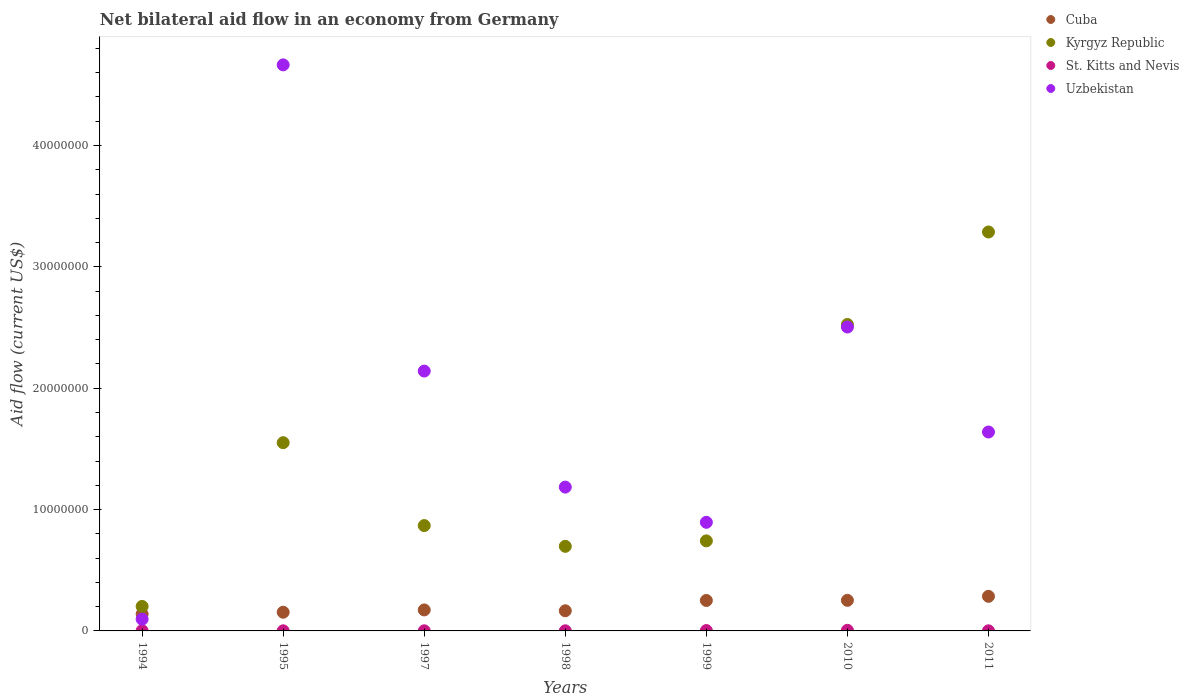What is the net bilateral aid flow in Cuba in 1995?
Provide a short and direct response. 1.54e+06. Across all years, what is the minimum net bilateral aid flow in Cuba?
Your response must be concise. 1.39e+06. What is the total net bilateral aid flow in Kyrgyz Republic in the graph?
Provide a short and direct response. 9.87e+07. What is the difference between the net bilateral aid flow in Uzbekistan in 1995 and that in 2010?
Make the answer very short. 2.16e+07. What is the difference between the net bilateral aid flow in Uzbekistan in 1999 and the net bilateral aid flow in Cuba in 2010?
Give a very brief answer. 6.43e+06. In the year 1997, what is the difference between the net bilateral aid flow in Cuba and net bilateral aid flow in Kyrgyz Republic?
Offer a terse response. -6.95e+06. What is the ratio of the net bilateral aid flow in Kyrgyz Republic in 1997 to that in 2011?
Offer a very short reply. 0.26. Is the net bilateral aid flow in Cuba in 1997 less than that in 1999?
Ensure brevity in your answer.  Yes. Is the difference between the net bilateral aid flow in Cuba in 1995 and 2011 greater than the difference between the net bilateral aid flow in Kyrgyz Republic in 1995 and 2011?
Provide a succinct answer. Yes. What is the difference between the highest and the second highest net bilateral aid flow in Cuba?
Ensure brevity in your answer.  3.30e+05. What is the difference between the highest and the lowest net bilateral aid flow in Uzbekistan?
Your response must be concise. 4.57e+07. In how many years, is the net bilateral aid flow in Uzbekistan greater than the average net bilateral aid flow in Uzbekistan taken over all years?
Your answer should be compact. 3. Is the sum of the net bilateral aid flow in Cuba in 1994 and 1998 greater than the maximum net bilateral aid flow in Uzbekistan across all years?
Offer a terse response. No. Does the net bilateral aid flow in Uzbekistan monotonically increase over the years?
Your answer should be compact. No. How many dotlines are there?
Provide a short and direct response. 4. How many years are there in the graph?
Your answer should be very brief. 7. What is the difference between two consecutive major ticks on the Y-axis?
Give a very brief answer. 1.00e+07. Does the graph contain any zero values?
Your response must be concise. No. Does the graph contain grids?
Offer a terse response. No. Where does the legend appear in the graph?
Your answer should be very brief. Top right. What is the title of the graph?
Provide a succinct answer. Net bilateral aid flow in an economy from Germany. What is the Aid flow (current US$) of Cuba in 1994?
Your answer should be very brief. 1.39e+06. What is the Aid flow (current US$) in Kyrgyz Republic in 1994?
Provide a succinct answer. 2.02e+06. What is the Aid flow (current US$) in Uzbekistan in 1994?
Keep it short and to the point. 9.70e+05. What is the Aid flow (current US$) in Cuba in 1995?
Keep it short and to the point. 1.54e+06. What is the Aid flow (current US$) of Kyrgyz Republic in 1995?
Offer a very short reply. 1.55e+07. What is the Aid flow (current US$) of Uzbekistan in 1995?
Your answer should be very brief. 4.66e+07. What is the Aid flow (current US$) of Cuba in 1997?
Make the answer very short. 1.73e+06. What is the Aid flow (current US$) in Kyrgyz Republic in 1997?
Keep it short and to the point. 8.68e+06. What is the Aid flow (current US$) in St. Kitts and Nevis in 1997?
Offer a terse response. 10000. What is the Aid flow (current US$) in Uzbekistan in 1997?
Ensure brevity in your answer.  2.14e+07. What is the Aid flow (current US$) of Cuba in 1998?
Give a very brief answer. 1.66e+06. What is the Aid flow (current US$) in Kyrgyz Republic in 1998?
Offer a very short reply. 6.97e+06. What is the Aid flow (current US$) in St. Kitts and Nevis in 1998?
Your answer should be very brief. 10000. What is the Aid flow (current US$) in Uzbekistan in 1998?
Provide a short and direct response. 1.18e+07. What is the Aid flow (current US$) in Cuba in 1999?
Offer a terse response. 2.51e+06. What is the Aid flow (current US$) in Kyrgyz Republic in 1999?
Your response must be concise. 7.42e+06. What is the Aid flow (current US$) in St. Kitts and Nevis in 1999?
Give a very brief answer. 3.00e+04. What is the Aid flow (current US$) in Uzbekistan in 1999?
Offer a terse response. 8.95e+06. What is the Aid flow (current US$) in Cuba in 2010?
Provide a succinct answer. 2.52e+06. What is the Aid flow (current US$) of Kyrgyz Republic in 2010?
Give a very brief answer. 2.52e+07. What is the Aid flow (current US$) in Uzbekistan in 2010?
Provide a short and direct response. 2.50e+07. What is the Aid flow (current US$) in Cuba in 2011?
Provide a short and direct response. 2.85e+06. What is the Aid flow (current US$) of Kyrgyz Republic in 2011?
Keep it short and to the point. 3.29e+07. What is the Aid flow (current US$) of Uzbekistan in 2011?
Your response must be concise. 1.64e+07. Across all years, what is the maximum Aid flow (current US$) in Cuba?
Offer a very short reply. 2.85e+06. Across all years, what is the maximum Aid flow (current US$) of Kyrgyz Republic?
Your answer should be compact. 3.29e+07. Across all years, what is the maximum Aid flow (current US$) of St. Kitts and Nevis?
Your response must be concise. 5.00e+04. Across all years, what is the maximum Aid flow (current US$) of Uzbekistan?
Your answer should be very brief. 4.66e+07. Across all years, what is the minimum Aid flow (current US$) in Cuba?
Your answer should be very brief. 1.39e+06. Across all years, what is the minimum Aid flow (current US$) of Kyrgyz Republic?
Offer a terse response. 2.02e+06. Across all years, what is the minimum Aid flow (current US$) of Uzbekistan?
Ensure brevity in your answer.  9.70e+05. What is the total Aid flow (current US$) in Cuba in the graph?
Offer a very short reply. 1.42e+07. What is the total Aid flow (current US$) of Kyrgyz Republic in the graph?
Keep it short and to the point. 9.87e+07. What is the total Aid flow (current US$) of St. Kitts and Nevis in the graph?
Keep it short and to the point. 1.40e+05. What is the total Aid flow (current US$) in Uzbekistan in the graph?
Your answer should be very brief. 1.31e+08. What is the difference between the Aid flow (current US$) in Kyrgyz Republic in 1994 and that in 1995?
Your answer should be very brief. -1.35e+07. What is the difference between the Aid flow (current US$) of Uzbekistan in 1994 and that in 1995?
Your response must be concise. -4.57e+07. What is the difference between the Aid flow (current US$) of Kyrgyz Republic in 1994 and that in 1997?
Offer a terse response. -6.66e+06. What is the difference between the Aid flow (current US$) in St. Kitts and Nevis in 1994 and that in 1997?
Provide a succinct answer. 10000. What is the difference between the Aid flow (current US$) in Uzbekistan in 1994 and that in 1997?
Make the answer very short. -2.04e+07. What is the difference between the Aid flow (current US$) of Kyrgyz Republic in 1994 and that in 1998?
Provide a succinct answer. -4.95e+06. What is the difference between the Aid flow (current US$) in St. Kitts and Nevis in 1994 and that in 1998?
Ensure brevity in your answer.  10000. What is the difference between the Aid flow (current US$) in Uzbekistan in 1994 and that in 1998?
Give a very brief answer. -1.09e+07. What is the difference between the Aid flow (current US$) in Cuba in 1994 and that in 1999?
Your response must be concise. -1.12e+06. What is the difference between the Aid flow (current US$) of Kyrgyz Republic in 1994 and that in 1999?
Offer a very short reply. -5.40e+06. What is the difference between the Aid flow (current US$) of Uzbekistan in 1994 and that in 1999?
Keep it short and to the point. -7.98e+06. What is the difference between the Aid flow (current US$) of Cuba in 1994 and that in 2010?
Keep it short and to the point. -1.13e+06. What is the difference between the Aid flow (current US$) of Kyrgyz Republic in 1994 and that in 2010?
Your answer should be compact. -2.32e+07. What is the difference between the Aid flow (current US$) of St. Kitts and Nevis in 1994 and that in 2010?
Give a very brief answer. -3.00e+04. What is the difference between the Aid flow (current US$) in Uzbekistan in 1994 and that in 2010?
Keep it short and to the point. -2.41e+07. What is the difference between the Aid flow (current US$) in Cuba in 1994 and that in 2011?
Offer a terse response. -1.46e+06. What is the difference between the Aid flow (current US$) of Kyrgyz Republic in 1994 and that in 2011?
Keep it short and to the point. -3.08e+07. What is the difference between the Aid flow (current US$) in Uzbekistan in 1994 and that in 2011?
Make the answer very short. -1.54e+07. What is the difference between the Aid flow (current US$) in Kyrgyz Republic in 1995 and that in 1997?
Provide a succinct answer. 6.83e+06. What is the difference between the Aid flow (current US$) of St. Kitts and Nevis in 1995 and that in 1997?
Provide a short and direct response. 0. What is the difference between the Aid flow (current US$) of Uzbekistan in 1995 and that in 1997?
Offer a very short reply. 2.52e+07. What is the difference between the Aid flow (current US$) in Kyrgyz Republic in 1995 and that in 1998?
Your answer should be very brief. 8.54e+06. What is the difference between the Aid flow (current US$) in St. Kitts and Nevis in 1995 and that in 1998?
Provide a short and direct response. 0. What is the difference between the Aid flow (current US$) in Uzbekistan in 1995 and that in 1998?
Your response must be concise. 3.48e+07. What is the difference between the Aid flow (current US$) in Cuba in 1995 and that in 1999?
Your answer should be very brief. -9.70e+05. What is the difference between the Aid flow (current US$) in Kyrgyz Republic in 1995 and that in 1999?
Give a very brief answer. 8.09e+06. What is the difference between the Aid flow (current US$) in Uzbekistan in 1995 and that in 1999?
Your answer should be very brief. 3.77e+07. What is the difference between the Aid flow (current US$) of Cuba in 1995 and that in 2010?
Provide a succinct answer. -9.80e+05. What is the difference between the Aid flow (current US$) of Kyrgyz Republic in 1995 and that in 2010?
Give a very brief answer. -9.74e+06. What is the difference between the Aid flow (current US$) of St. Kitts and Nevis in 1995 and that in 2010?
Give a very brief answer. -4.00e+04. What is the difference between the Aid flow (current US$) in Uzbekistan in 1995 and that in 2010?
Your answer should be compact. 2.16e+07. What is the difference between the Aid flow (current US$) of Cuba in 1995 and that in 2011?
Give a very brief answer. -1.31e+06. What is the difference between the Aid flow (current US$) in Kyrgyz Republic in 1995 and that in 2011?
Provide a short and direct response. -1.74e+07. What is the difference between the Aid flow (current US$) of Uzbekistan in 1995 and that in 2011?
Offer a terse response. 3.02e+07. What is the difference between the Aid flow (current US$) of Cuba in 1997 and that in 1998?
Offer a terse response. 7.00e+04. What is the difference between the Aid flow (current US$) of Kyrgyz Republic in 1997 and that in 1998?
Keep it short and to the point. 1.71e+06. What is the difference between the Aid flow (current US$) of St. Kitts and Nevis in 1997 and that in 1998?
Your answer should be very brief. 0. What is the difference between the Aid flow (current US$) in Uzbekistan in 1997 and that in 1998?
Keep it short and to the point. 9.56e+06. What is the difference between the Aid flow (current US$) in Cuba in 1997 and that in 1999?
Provide a succinct answer. -7.80e+05. What is the difference between the Aid flow (current US$) of Kyrgyz Republic in 1997 and that in 1999?
Offer a terse response. 1.26e+06. What is the difference between the Aid flow (current US$) in St. Kitts and Nevis in 1997 and that in 1999?
Your response must be concise. -2.00e+04. What is the difference between the Aid flow (current US$) of Uzbekistan in 1997 and that in 1999?
Your answer should be compact. 1.25e+07. What is the difference between the Aid flow (current US$) in Cuba in 1997 and that in 2010?
Offer a very short reply. -7.90e+05. What is the difference between the Aid flow (current US$) of Kyrgyz Republic in 1997 and that in 2010?
Provide a succinct answer. -1.66e+07. What is the difference between the Aid flow (current US$) in St. Kitts and Nevis in 1997 and that in 2010?
Offer a terse response. -4.00e+04. What is the difference between the Aid flow (current US$) in Uzbekistan in 1997 and that in 2010?
Your response must be concise. -3.63e+06. What is the difference between the Aid flow (current US$) of Cuba in 1997 and that in 2011?
Provide a short and direct response. -1.12e+06. What is the difference between the Aid flow (current US$) in Kyrgyz Republic in 1997 and that in 2011?
Ensure brevity in your answer.  -2.42e+07. What is the difference between the Aid flow (current US$) of St. Kitts and Nevis in 1997 and that in 2011?
Give a very brief answer. 0. What is the difference between the Aid flow (current US$) in Uzbekistan in 1997 and that in 2011?
Ensure brevity in your answer.  5.02e+06. What is the difference between the Aid flow (current US$) in Cuba in 1998 and that in 1999?
Ensure brevity in your answer.  -8.50e+05. What is the difference between the Aid flow (current US$) of Kyrgyz Republic in 1998 and that in 1999?
Keep it short and to the point. -4.50e+05. What is the difference between the Aid flow (current US$) of St. Kitts and Nevis in 1998 and that in 1999?
Your response must be concise. -2.00e+04. What is the difference between the Aid flow (current US$) in Uzbekistan in 1998 and that in 1999?
Your response must be concise. 2.90e+06. What is the difference between the Aid flow (current US$) of Cuba in 1998 and that in 2010?
Offer a very short reply. -8.60e+05. What is the difference between the Aid flow (current US$) of Kyrgyz Republic in 1998 and that in 2010?
Offer a terse response. -1.83e+07. What is the difference between the Aid flow (current US$) in St. Kitts and Nevis in 1998 and that in 2010?
Make the answer very short. -4.00e+04. What is the difference between the Aid flow (current US$) of Uzbekistan in 1998 and that in 2010?
Your answer should be compact. -1.32e+07. What is the difference between the Aid flow (current US$) of Cuba in 1998 and that in 2011?
Provide a short and direct response. -1.19e+06. What is the difference between the Aid flow (current US$) of Kyrgyz Republic in 1998 and that in 2011?
Offer a very short reply. -2.59e+07. What is the difference between the Aid flow (current US$) in Uzbekistan in 1998 and that in 2011?
Your answer should be compact. -4.54e+06. What is the difference between the Aid flow (current US$) of Kyrgyz Republic in 1999 and that in 2010?
Ensure brevity in your answer.  -1.78e+07. What is the difference between the Aid flow (current US$) of St. Kitts and Nevis in 1999 and that in 2010?
Give a very brief answer. -2.00e+04. What is the difference between the Aid flow (current US$) in Uzbekistan in 1999 and that in 2010?
Offer a very short reply. -1.61e+07. What is the difference between the Aid flow (current US$) in Kyrgyz Republic in 1999 and that in 2011?
Ensure brevity in your answer.  -2.54e+07. What is the difference between the Aid flow (current US$) of St. Kitts and Nevis in 1999 and that in 2011?
Make the answer very short. 2.00e+04. What is the difference between the Aid flow (current US$) of Uzbekistan in 1999 and that in 2011?
Your response must be concise. -7.44e+06. What is the difference between the Aid flow (current US$) in Cuba in 2010 and that in 2011?
Your answer should be very brief. -3.30e+05. What is the difference between the Aid flow (current US$) in Kyrgyz Republic in 2010 and that in 2011?
Offer a terse response. -7.62e+06. What is the difference between the Aid flow (current US$) of St. Kitts and Nevis in 2010 and that in 2011?
Give a very brief answer. 4.00e+04. What is the difference between the Aid flow (current US$) in Uzbekistan in 2010 and that in 2011?
Your answer should be compact. 8.65e+06. What is the difference between the Aid flow (current US$) in Cuba in 1994 and the Aid flow (current US$) in Kyrgyz Republic in 1995?
Your response must be concise. -1.41e+07. What is the difference between the Aid flow (current US$) in Cuba in 1994 and the Aid flow (current US$) in St. Kitts and Nevis in 1995?
Your response must be concise. 1.38e+06. What is the difference between the Aid flow (current US$) of Cuba in 1994 and the Aid flow (current US$) of Uzbekistan in 1995?
Provide a short and direct response. -4.52e+07. What is the difference between the Aid flow (current US$) in Kyrgyz Republic in 1994 and the Aid flow (current US$) in St. Kitts and Nevis in 1995?
Your answer should be compact. 2.01e+06. What is the difference between the Aid flow (current US$) of Kyrgyz Republic in 1994 and the Aid flow (current US$) of Uzbekistan in 1995?
Your response must be concise. -4.46e+07. What is the difference between the Aid flow (current US$) in St. Kitts and Nevis in 1994 and the Aid flow (current US$) in Uzbekistan in 1995?
Provide a short and direct response. -4.66e+07. What is the difference between the Aid flow (current US$) of Cuba in 1994 and the Aid flow (current US$) of Kyrgyz Republic in 1997?
Provide a succinct answer. -7.29e+06. What is the difference between the Aid flow (current US$) in Cuba in 1994 and the Aid flow (current US$) in St. Kitts and Nevis in 1997?
Your answer should be very brief. 1.38e+06. What is the difference between the Aid flow (current US$) of Cuba in 1994 and the Aid flow (current US$) of Uzbekistan in 1997?
Your response must be concise. -2.00e+07. What is the difference between the Aid flow (current US$) of Kyrgyz Republic in 1994 and the Aid flow (current US$) of St. Kitts and Nevis in 1997?
Keep it short and to the point. 2.01e+06. What is the difference between the Aid flow (current US$) of Kyrgyz Republic in 1994 and the Aid flow (current US$) of Uzbekistan in 1997?
Offer a terse response. -1.94e+07. What is the difference between the Aid flow (current US$) in St. Kitts and Nevis in 1994 and the Aid flow (current US$) in Uzbekistan in 1997?
Offer a very short reply. -2.14e+07. What is the difference between the Aid flow (current US$) of Cuba in 1994 and the Aid flow (current US$) of Kyrgyz Republic in 1998?
Your answer should be very brief. -5.58e+06. What is the difference between the Aid flow (current US$) in Cuba in 1994 and the Aid flow (current US$) in St. Kitts and Nevis in 1998?
Provide a short and direct response. 1.38e+06. What is the difference between the Aid flow (current US$) of Cuba in 1994 and the Aid flow (current US$) of Uzbekistan in 1998?
Provide a short and direct response. -1.05e+07. What is the difference between the Aid flow (current US$) in Kyrgyz Republic in 1994 and the Aid flow (current US$) in St. Kitts and Nevis in 1998?
Your answer should be compact. 2.01e+06. What is the difference between the Aid flow (current US$) of Kyrgyz Republic in 1994 and the Aid flow (current US$) of Uzbekistan in 1998?
Ensure brevity in your answer.  -9.83e+06. What is the difference between the Aid flow (current US$) of St. Kitts and Nevis in 1994 and the Aid flow (current US$) of Uzbekistan in 1998?
Offer a very short reply. -1.18e+07. What is the difference between the Aid flow (current US$) in Cuba in 1994 and the Aid flow (current US$) in Kyrgyz Republic in 1999?
Keep it short and to the point. -6.03e+06. What is the difference between the Aid flow (current US$) in Cuba in 1994 and the Aid flow (current US$) in St. Kitts and Nevis in 1999?
Keep it short and to the point. 1.36e+06. What is the difference between the Aid flow (current US$) of Cuba in 1994 and the Aid flow (current US$) of Uzbekistan in 1999?
Make the answer very short. -7.56e+06. What is the difference between the Aid flow (current US$) in Kyrgyz Republic in 1994 and the Aid flow (current US$) in St. Kitts and Nevis in 1999?
Your answer should be very brief. 1.99e+06. What is the difference between the Aid flow (current US$) of Kyrgyz Republic in 1994 and the Aid flow (current US$) of Uzbekistan in 1999?
Ensure brevity in your answer.  -6.93e+06. What is the difference between the Aid flow (current US$) in St. Kitts and Nevis in 1994 and the Aid flow (current US$) in Uzbekistan in 1999?
Your answer should be very brief. -8.93e+06. What is the difference between the Aid flow (current US$) in Cuba in 1994 and the Aid flow (current US$) in Kyrgyz Republic in 2010?
Provide a short and direct response. -2.39e+07. What is the difference between the Aid flow (current US$) in Cuba in 1994 and the Aid flow (current US$) in St. Kitts and Nevis in 2010?
Ensure brevity in your answer.  1.34e+06. What is the difference between the Aid flow (current US$) of Cuba in 1994 and the Aid flow (current US$) of Uzbekistan in 2010?
Provide a succinct answer. -2.36e+07. What is the difference between the Aid flow (current US$) of Kyrgyz Republic in 1994 and the Aid flow (current US$) of St. Kitts and Nevis in 2010?
Your answer should be compact. 1.97e+06. What is the difference between the Aid flow (current US$) of Kyrgyz Republic in 1994 and the Aid flow (current US$) of Uzbekistan in 2010?
Your response must be concise. -2.30e+07. What is the difference between the Aid flow (current US$) in St. Kitts and Nevis in 1994 and the Aid flow (current US$) in Uzbekistan in 2010?
Your answer should be compact. -2.50e+07. What is the difference between the Aid flow (current US$) of Cuba in 1994 and the Aid flow (current US$) of Kyrgyz Republic in 2011?
Make the answer very short. -3.15e+07. What is the difference between the Aid flow (current US$) of Cuba in 1994 and the Aid flow (current US$) of St. Kitts and Nevis in 2011?
Your answer should be compact. 1.38e+06. What is the difference between the Aid flow (current US$) of Cuba in 1994 and the Aid flow (current US$) of Uzbekistan in 2011?
Ensure brevity in your answer.  -1.50e+07. What is the difference between the Aid flow (current US$) in Kyrgyz Republic in 1994 and the Aid flow (current US$) in St. Kitts and Nevis in 2011?
Make the answer very short. 2.01e+06. What is the difference between the Aid flow (current US$) in Kyrgyz Republic in 1994 and the Aid flow (current US$) in Uzbekistan in 2011?
Ensure brevity in your answer.  -1.44e+07. What is the difference between the Aid flow (current US$) of St. Kitts and Nevis in 1994 and the Aid flow (current US$) of Uzbekistan in 2011?
Make the answer very short. -1.64e+07. What is the difference between the Aid flow (current US$) in Cuba in 1995 and the Aid flow (current US$) in Kyrgyz Republic in 1997?
Your answer should be compact. -7.14e+06. What is the difference between the Aid flow (current US$) in Cuba in 1995 and the Aid flow (current US$) in St. Kitts and Nevis in 1997?
Your response must be concise. 1.53e+06. What is the difference between the Aid flow (current US$) of Cuba in 1995 and the Aid flow (current US$) of Uzbekistan in 1997?
Keep it short and to the point. -1.99e+07. What is the difference between the Aid flow (current US$) of Kyrgyz Republic in 1995 and the Aid flow (current US$) of St. Kitts and Nevis in 1997?
Offer a very short reply. 1.55e+07. What is the difference between the Aid flow (current US$) in Kyrgyz Republic in 1995 and the Aid flow (current US$) in Uzbekistan in 1997?
Provide a succinct answer. -5.90e+06. What is the difference between the Aid flow (current US$) in St. Kitts and Nevis in 1995 and the Aid flow (current US$) in Uzbekistan in 1997?
Keep it short and to the point. -2.14e+07. What is the difference between the Aid flow (current US$) in Cuba in 1995 and the Aid flow (current US$) in Kyrgyz Republic in 1998?
Make the answer very short. -5.43e+06. What is the difference between the Aid flow (current US$) of Cuba in 1995 and the Aid flow (current US$) of St. Kitts and Nevis in 1998?
Offer a terse response. 1.53e+06. What is the difference between the Aid flow (current US$) in Cuba in 1995 and the Aid flow (current US$) in Uzbekistan in 1998?
Your answer should be very brief. -1.03e+07. What is the difference between the Aid flow (current US$) of Kyrgyz Republic in 1995 and the Aid flow (current US$) of St. Kitts and Nevis in 1998?
Make the answer very short. 1.55e+07. What is the difference between the Aid flow (current US$) of Kyrgyz Republic in 1995 and the Aid flow (current US$) of Uzbekistan in 1998?
Your answer should be compact. 3.66e+06. What is the difference between the Aid flow (current US$) of St. Kitts and Nevis in 1995 and the Aid flow (current US$) of Uzbekistan in 1998?
Ensure brevity in your answer.  -1.18e+07. What is the difference between the Aid flow (current US$) of Cuba in 1995 and the Aid flow (current US$) of Kyrgyz Republic in 1999?
Make the answer very short. -5.88e+06. What is the difference between the Aid flow (current US$) in Cuba in 1995 and the Aid flow (current US$) in St. Kitts and Nevis in 1999?
Provide a succinct answer. 1.51e+06. What is the difference between the Aid flow (current US$) in Cuba in 1995 and the Aid flow (current US$) in Uzbekistan in 1999?
Make the answer very short. -7.41e+06. What is the difference between the Aid flow (current US$) in Kyrgyz Republic in 1995 and the Aid flow (current US$) in St. Kitts and Nevis in 1999?
Your answer should be compact. 1.55e+07. What is the difference between the Aid flow (current US$) in Kyrgyz Republic in 1995 and the Aid flow (current US$) in Uzbekistan in 1999?
Offer a terse response. 6.56e+06. What is the difference between the Aid flow (current US$) of St. Kitts and Nevis in 1995 and the Aid flow (current US$) of Uzbekistan in 1999?
Give a very brief answer. -8.94e+06. What is the difference between the Aid flow (current US$) of Cuba in 1995 and the Aid flow (current US$) of Kyrgyz Republic in 2010?
Make the answer very short. -2.37e+07. What is the difference between the Aid flow (current US$) in Cuba in 1995 and the Aid flow (current US$) in St. Kitts and Nevis in 2010?
Keep it short and to the point. 1.49e+06. What is the difference between the Aid flow (current US$) of Cuba in 1995 and the Aid flow (current US$) of Uzbekistan in 2010?
Keep it short and to the point. -2.35e+07. What is the difference between the Aid flow (current US$) of Kyrgyz Republic in 1995 and the Aid flow (current US$) of St. Kitts and Nevis in 2010?
Ensure brevity in your answer.  1.55e+07. What is the difference between the Aid flow (current US$) in Kyrgyz Republic in 1995 and the Aid flow (current US$) in Uzbekistan in 2010?
Provide a short and direct response. -9.53e+06. What is the difference between the Aid flow (current US$) of St. Kitts and Nevis in 1995 and the Aid flow (current US$) of Uzbekistan in 2010?
Give a very brief answer. -2.50e+07. What is the difference between the Aid flow (current US$) in Cuba in 1995 and the Aid flow (current US$) in Kyrgyz Republic in 2011?
Provide a succinct answer. -3.13e+07. What is the difference between the Aid flow (current US$) of Cuba in 1995 and the Aid flow (current US$) of St. Kitts and Nevis in 2011?
Ensure brevity in your answer.  1.53e+06. What is the difference between the Aid flow (current US$) of Cuba in 1995 and the Aid flow (current US$) of Uzbekistan in 2011?
Ensure brevity in your answer.  -1.48e+07. What is the difference between the Aid flow (current US$) of Kyrgyz Republic in 1995 and the Aid flow (current US$) of St. Kitts and Nevis in 2011?
Your answer should be very brief. 1.55e+07. What is the difference between the Aid flow (current US$) of Kyrgyz Republic in 1995 and the Aid flow (current US$) of Uzbekistan in 2011?
Offer a terse response. -8.80e+05. What is the difference between the Aid flow (current US$) in St. Kitts and Nevis in 1995 and the Aid flow (current US$) in Uzbekistan in 2011?
Offer a terse response. -1.64e+07. What is the difference between the Aid flow (current US$) of Cuba in 1997 and the Aid flow (current US$) of Kyrgyz Republic in 1998?
Your answer should be very brief. -5.24e+06. What is the difference between the Aid flow (current US$) in Cuba in 1997 and the Aid flow (current US$) in St. Kitts and Nevis in 1998?
Give a very brief answer. 1.72e+06. What is the difference between the Aid flow (current US$) in Cuba in 1997 and the Aid flow (current US$) in Uzbekistan in 1998?
Keep it short and to the point. -1.01e+07. What is the difference between the Aid flow (current US$) in Kyrgyz Republic in 1997 and the Aid flow (current US$) in St. Kitts and Nevis in 1998?
Provide a succinct answer. 8.67e+06. What is the difference between the Aid flow (current US$) of Kyrgyz Republic in 1997 and the Aid flow (current US$) of Uzbekistan in 1998?
Offer a very short reply. -3.17e+06. What is the difference between the Aid flow (current US$) in St. Kitts and Nevis in 1997 and the Aid flow (current US$) in Uzbekistan in 1998?
Your answer should be very brief. -1.18e+07. What is the difference between the Aid flow (current US$) in Cuba in 1997 and the Aid flow (current US$) in Kyrgyz Republic in 1999?
Provide a succinct answer. -5.69e+06. What is the difference between the Aid flow (current US$) in Cuba in 1997 and the Aid flow (current US$) in St. Kitts and Nevis in 1999?
Provide a succinct answer. 1.70e+06. What is the difference between the Aid flow (current US$) of Cuba in 1997 and the Aid flow (current US$) of Uzbekistan in 1999?
Offer a very short reply. -7.22e+06. What is the difference between the Aid flow (current US$) of Kyrgyz Republic in 1997 and the Aid flow (current US$) of St. Kitts and Nevis in 1999?
Make the answer very short. 8.65e+06. What is the difference between the Aid flow (current US$) of St. Kitts and Nevis in 1997 and the Aid flow (current US$) of Uzbekistan in 1999?
Offer a terse response. -8.94e+06. What is the difference between the Aid flow (current US$) in Cuba in 1997 and the Aid flow (current US$) in Kyrgyz Republic in 2010?
Your answer should be very brief. -2.35e+07. What is the difference between the Aid flow (current US$) of Cuba in 1997 and the Aid flow (current US$) of St. Kitts and Nevis in 2010?
Offer a very short reply. 1.68e+06. What is the difference between the Aid flow (current US$) of Cuba in 1997 and the Aid flow (current US$) of Uzbekistan in 2010?
Keep it short and to the point. -2.33e+07. What is the difference between the Aid flow (current US$) in Kyrgyz Republic in 1997 and the Aid flow (current US$) in St. Kitts and Nevis in 2010?
Make the answer very short. 8.63e+06. What is the difference between the Aid flow (current US$) in Kyrgyz Republic in 1997 and the Aid flow (current US$) in Uzbekistan in 2010?
Give a very brief answer. -1.64e+07. What is the difference between the Aid flow (current US$) of St. Kitts and Nevis in 1997 and the Aid flow (current US$) of Uzbekistan in 2010?
Ensure brevity in your answer.  -2.50e+07. What is the difference between the Aid flow (current US$) in Cuba in 1997 and the Aid flow (current US$) in Kyrgyz Republic in 2011?
Your response must be concise. -3.11e+07. What is the difference between the Aid flow (current US$) of Cuba in 1997 and the Aid flow (current US$) of St. Kitts and Nevis in 2011?
Give a very brief answer. 1.72e+06. What is the difference between the Aid flow (current US$) of Cuba in 1997 and the Aid flow (current US$) of Uzbekistan in 2011?
Give a very brief answer. -1.47e+07. What is the difference between the Aid flow (current US$) in Kyrgyz Republic in 1997 and the Aid flow (current US$) in St. Kitts and Nevis in 2011?
Offer a very short reply. 8.67e+06. What is the difference between the Aid flow (current US$) in Kyrgyz Republic in 1997 and the Aid flow (current US$) in Uzbekistan in 2011?
Offer a very short reply. -7.71e+06. What is the difference between the Aid flow (current US$) in St. Kitts and Nevis in 1997 and the Aid flow (current US$) in Uzbekistan in 2011?
Make the answer very short. -1.64e+07. What is the difference between the Aid flow (current US$) of Cuba in 1998 and the Aid flow (current US$) of Kyrgyz Republic in 1999?
Offer a terse response. -5.76e+06. What is the difference between the Aid flow (current US$) in Cuba in 1998 and the Aid flow (current US$) in St. Kitts and Nevis in 1999?
Your answer should be compact. 1.63e+06. What is the difference between the Aid flow (current US$) in Cuba in 1998 and the Aid flow (current US$) in Uzbekistan in 1999?
Keep it short and to the point. -7.29e+06. What is the difference between the Aid flow (current US$) in Kyrgyz Republic in 1998 and the Aid flow (current US$) in St. Kitts and Nevis in 1999?
Ensure brevity in your answer.  6.94e+06. What is the difference between the Aid flow (current US$) of Kyrgyz Republic in 1998 and the Aid flow (current US$) of Uzbekistan in 1999?
Give a very brief answer. -1.98e+06. What is the difference between the Aid flow (current US$) of St. Kitts and Nevis in 1998 and the Aid flow (current US$) of Uzbekistan in 1999?
Provide a short and direct response. -8.94e+06. What is the difference between the Aid flow (current US$) in Cuba in 1998 and the Aid flow (current US$) in Kyrgyz Republic in 2010?
Keep it short and to the point. -2.36e+07. What is the difference between the Aid flow (current US$) in Cuba in 1998 and the Aid flow (current US$) in St. Kitts and Nevis in 2010?
Provide a succinct answer. 1.61e+06. What is the difference between the Aid flow (current US$) of Cuba in 1998 and the Aid flow (current US$) of Uzbekistan in 2010?
Offer a terse response. -2.34e+07. What is the difference between the Aid flow (current US$) of Kyrgyz Republic in 1998 and the Aid flow (current US$) of St. Kitts and Nevis in 2010?
Provide a succinct answer. 6.92e+06. What is the difference between the Aid flow (current US$) of Kyrgyz Republic in 1998 and the Aid flow (current US$) of Uzbekistan in 2010?
Give a very brief answer. -1.81e+07. What is the difference between the Aid flow (current US$) of St. Kitts and Nevis in 1998 and the Aid flow (current US$) of Uzbekistan in 2010?
Provide a succinct answer. -2.50e+07. What is the difference between the Aid flow (current US$) of Cuba in 1998 and the Aid flow (current US$) of Kyrgyz Republic in 2011?
Provide a succinct answer. -3.12e+07. What is the difference between the Aid flow (current US$) of Cuba in 1998 and the Aid flow (current US$) of St. Kitts and Nevis in 2011?
Your response must be concise. 1.65e+06. What is the difference between the Aid flow (current US$) of Cuba in 1998 and the Aid flow (current US$) of Uzbekistan in 2011?
Provide a short and direct response. -1.47e+07. What is the difference between the Aid flow (current US$) of Kyrgyz Republic in 1998 and the Aid flow (current US$) of St. Kitts and Nevis in 2011?
Provide a short and direct response. 6.96e+06. What is the difference between the Aid flow (current US$) of Kyrgyz Republic in 1998 and the Aid flow (current US$) of Uzbekistan in 2011?
Your answer should be compact. -9.42e+06. What is the difference between the Aid flow (current US$) in St. Kitts and Nevis in 1998 and the Aid flow (current US$) in Uzbekistan in 2011?
Give a very brief answer. -1.64e+07. What is the difference between the Aid flow (current US$) in Cuba in 1999 and the Aid flow (current US$) in Kyrgyz Republic in 2010?
Provide a succinct answer. -2.27e+07. What is the difference between the Aid flow (current US$) in Cuba in 1999 and the Aid flow (current US$) in St. Kitts and Nevis in 2010?
Your answer should be very brief. 2.46e+06. What is the difference between the Aid flow (current US$) of Cuba in 1999 and the Aid flow (current US$) of Uzbekistan in 2010?
Your answer should be compact. -2.25e+07. What is the difference between the Aid flow (current US$) in Kyrgyz Republic in 1999 and the Aid flow (current US$) in St. Kitts and Nevis in 2010?
Offer a very short reply. 7.37e+06. What is the difference between the Aid flow (current US$) in Kyrgyz Republic in 1999 and the Aid flow (current US$) in Uzbekistan in 2010?
Provide a succinct answer. -1.76e+07. What is the difference between the Aid flow (current US$) in St. Kitts and Nevis in 1999 and the Aid flow (current US$) in Uzbekistan in 2010?
Your answer should be compact. -2.50e+07. What is the difference between the Aid flow (current US$) of Cuba in 1999 and the Aid flow (current US$) of Kyrgyz Republic in 2011?
Provide a short and direct response. -3.04e+07. What is the difference between the Aid flow (current US$) in Cuba in 1999 and the Aid flow (current US$) in St. Kitts and Nevis in 2011?
Ensure brevity in your answer.  2.50e+06. What is the difference between the Aid flow (current US$) in Cuba in 1999 and the Aid flow (current US$) in Uzbekistan in 2011?
Your response must be concise. -1.39e+07. What is the difference between the Aid flow (current US$) of Kyrgyz Republic in 1999 and the Aid flow (current US$) of St. Kitts and Nevis in 2011?
Offer a very short reply. 7.41e+06. What is the difference between the Aid flow (current US$) of Kyrgyz Republic in 1999 and the Aid flow (current US$) of Uzbekistan in 2011?
Give a very brief answer. -8.97e+06. What is the difference between the Aid flow (current US$) in St. Kitts and Nevis in 1999 and the Aid flow (current US$) in Uzbekistan in 2011?
Provide a succinct answer. -1.64e+07. What is the difference between the Aid flow (current US$) of Cuba in 2010 and the Aid flow (current US$) of Kyrgyz Republic in 2011?
Give a very brief answer. -3.04e+07. What is the difference between the Aid flow (current US$) in Cuba in 2010 and the Aid flow (current US$) in St. Kitts and Nevis in 2011?
Ensure brevity in your answer.  2.51e+06. What is the difference between the Aid flow (current US$) of Cuba in 2010 and the Aid flow (current US$) of Uzbekistan in 2011?
Your response must be concise. -1.39e+07. What is the difference between the Aid flow (current US$) in Kyrgyz Republic in 2010 and the Aid flow (current US$) in St. Kitts and Nevis in 2011?
Make the answer very short. 2.52e+07. What is the difference between the Aid flow (current US$) in Kyrgyz Republic in 2010 and the Aid flow (current US$) in Uzbekistan in 2011?
Provide a short and direct response. 8.86e+06. What is the difference between the Aid flow (current US$) of St. Kitts and Nevis in 2010 and the Aid flow (current US$) of Uzbekistan in 2011?
Your answer should be very brief. -1.63e+07. What is the average Aid flow (current US$) of Cuba per year?
Your answer should be compact. 2.03e+06. What is the average Aid flow (current US$) in Kyrgyz Republic per year?
Your answer should be very brief. 1.41e+07. What is the average Aid flow (current US$) of Uzbekistan per year?
Offer a very short reply. 1.88e+07. In the year 1994, what is the difference between the Aid flow (current US$) in Cuba and Aid flow (current US$) in Kyrgyz Republic?
Keep it short and to the point. -6.30e+05. In the year 1994, what is the difference between the Aid flow (current US$) in Cuba and Aid flow (current US$) in St. Kitts and Nevis?
Your answer should be compact. 1.37e+06. In the year 1994, what is the difference between the Aid flow (current US$) of Cuba and Aid flow (current US$) of Uzbekistan?
Make the answer very short. 4.20e+05. In the year 1994, what is the difference between the Aid flow (current US$) of Kyrgyz Republic and Aid flow (current US$) of Uzbekistan?
Give a very brief answer. 1.05e+06. In the year 1994, what is the difference between the Aid flow (current US$) of St. Kitts and Nevis and Aid flow (current US$) of Uzbekistan?
Make the answer very short. -9.50e+05. In the year 1995, what is the difference between the Aid flow (current US$) of Cuba and Aid flow (current US$) of Kyrgyz Republic?
Offer a very short reply. -1.40e+07. In the year 1995, what is the difference between the Aid flow (current US$) in Cuba and Aid flow (current US$) in St. Kitts and Nevis?
Offer a terse response. 1.53e+06. In the year 1995, what is the difference between the Aid flow (current US$) of Cuba and Aid flow (current US$) of Uzbekistan?
Ensure brevity in your answer.  -4.51e+07. In the year 1995, what is the difference between the Aid flow (current US$) in Kyrgyz Republic and Aid flow (current US$) in St. Kitts and Nevis?
Your response must be concise. 1.55e+07. In the year 1995, what is the difference between the Aid flow (current US$) of Kyrgyz Republic and Aid flow (current US$) of Uzbekistan?
Give a very brief answer. -3.11e+07. In the year 1995, what is the difference between the Aid flow (current US$) of St. Kitts and Nevis and Aid flow (current US$) of Uzbekistan?
Make the answer very short. -4.66e+07. In the year 1997, what is the difference between the Aid flow (current US$) of Cuba and Aid flow (current US$) of Kyrgyz Republic?
Keep it short and to the point. -6.95e+06. In the year 1997, what is the difference between the Aid flow (current US$) of Cuba and Aid flow (current US$) of St. Kitts and Nevis?
Provide a succinct answer. 1.72e+06. In the year 1997, what is the difference between the Aid flow (current US$) of Cuba and Aid flow (current US$) of Uzbekistan?
Provide a succinct answer. -1.97e+07. In the year 1997, what is the difference between the Aid flow (current US$) of Kyrgyz Republic and Aid flow (current US$) of St. Kitts and Nevis?
Your answer should be compact. 8.67e+06. In the year 1997, what is the difference between the Aid flow (current US$) in Kyrgyz Republic and Aid flow (current US$) in Uzbekistan?
Give a very brief answer. -1.27e+07. In the year 1997, what is the difference between the Aid flow (current US$) of St. Kitts and Nevis and Aid flow (current US$) of Uzbekistan?
Keep it short and to the point. -2.14e+07. In the year 1998, what is the difference between the Aid flow (current US$) of Cuba and Aid flow (current US$) of Kyrgyz Republic?
Your answer should be compact. -5.31e+06. In the year 1998, what is the difference between the Aid flow (current US$) of Cuba and Aid flow (current US$) of St. Kitts and Nevis?
Make the answer very short. 1.65e+06. In the year 1998, what is the difference between the Aid flow (current US$) in Cuba and Aid flow (current US$) in Uzbekistan?
Offer a very short reply. -1.02e+07. In the year 1998, what is the difference between the Aid flow (current US$) of Kyrgyz Republic and Aid flow (current US$) of St. Kitts and Nevis?
Provide a short and direct response. 6.96e+06. In the year 1998, what is the difference between the Aid flow (current US$) of Kyrgyz Republic and Aid flow (current US$) of Uzbekistan?
Keep it short and to the point. -4.88e+06. In the year 1998, what is the difference between the Aid flow (current US$) of St. Kitts and Nevis and Aid flow (current US$) of Uzbekistan?
Your answer should be compact. -1.18e+07. In the year 1999, what is the difference between the Aid flow (current US$) of Cuba and Aid flow (current US$) of Kyrgyz Republic?
Keep it short and to the point. -4.91e+06. In the year 1999, what is the difference between the Aid flow (current US$) of Cuba and Aid flow (current US$) of St. Kitts and Nevis?
Your answer should be compact. 2.48e+06. In the year 1999, what is the difference between the Aid flow (current US$) in Cuba and Aid flow (current US$) in Uzbekistan?
Offer a very short reply. -6.44e+06. In the year 1999, what is the difference between the Aid flow (current US$) of Kyrgyz Republic and Aid flow (current US$) of St. Kitts and Nevis?
Provide a short and direct response. 7.39e+06. In the year 1999, what is the difference between the Aid flow (current US$) in Kyrgyz Republic and Aid flow (current US$) in Uzbekistan?
Offer a very short reply. -1.53e+06. In the year 1999, what is the difference between the Aid flow (current US$) in St. Kitts and Nevis and Aid flow (current US$) in Uzbekistan?
Provide a short and direct response. -8.92e+06. In the year 2010, what is the difference between the Aid flow (current US$) in Cuba and Aid flow (current US$) in Kyrgyz Republic?
Your response must be concise. -2.27e+07. In the year 2010, what is the difference between the Aid flow (current US$) of Cuba and Aid flow (current US$) of St. Kitts and Nevis?
Make the answer very short. 2.47e+06. In the year 2010, what is the difference between the Aid flow (current US$) in Cuba and Aid flow (current US$) in Uzbekistan?
Your response must be concise. -2.25e+07. In the year 2010, what is the difference between the Aid flow (current US$) of Kyrgyz Republic and Aid flow (current US$) of St. Kitts and Nevis?
Keep it short and to the point. 2.52e+07. In the year 2010, what is the difference between the Aid flow (current US$) in Kyrgyz Republic and Aid flow (current US$) in Uzbekistan?
Make the answer very short. 2.10e+05. In the year 2010, what is the difference between the Aid flow (current US$) of St. Kitts and Nevis and Aid flow (current US$) of Uzbekistan?
Your answer should be compact. -2.50e+07. In the year 2011, what is the difference between the Aid flow (current US$) in Cuba and Aid flow (current US$) in Kyrgyz Republic?
Offer a very short reply. -3.00e+07. In the year 2011, what is the difference between the Aid flow (current US$) in Cuba and Aid flow (current US$) in St. Kitts and Nevis?
Make the answer very short. 2.84e+06. In the year 2011, what is the difference between the Aid flow (current US$) in Cuba and Aid flow (current US$) in Uzbekistan?
Your answer should be very brief. -1.35e+07. In the year 2011, what is the difference between the Aid flow (current US$) in Kyrgyz Republic and Aid flow (current US$) in St. Kitts and Nevis?
Your answer should be compact. 3.29e+07. In the year 2011, what is the difference between the Aid flow (current US$) of Kyrgyz Republic and Aid flow (current US$) of Uzbekistan?
Your answer should be very brief. 1.65e+07. In the year 2011, what is the difference between the Aid flow (current US$) of St. Kitts and Nevis and Aid flow (current US$) of Uzbekistan?
Offer a terse response. -1.64e+07. What is the ratio of the Aid flow (current US$) of Cuba in 1994 to that in 1995?
Offer a very short reply. 0.9. What is the ratio of the Aid flow (current US$) of Kyrgyz Republic in 1994 to that in 1995?
Your response must be concise. 0.13. What is the ratio of the Aid flow (current US$) of St. Kitts and Nevis in 1994 to that in 1995?
Your answer should be compact. 2. What is the ratio of the Aid flow (current US$) of Uzbekistan in 1994 to that in 1995?
Give a very brief answer. 0.02. What is the ratio of the Aid flow (current US$) of Cuba in 1994 to that in 1997?
Make the answer very short. 0.8. What is the ratio of the Aid flow (current US$) in Kyrgyz Republic in 1994 to that in 1997?
Offer a very short reply. 0.23. What is the ratio of the Aid flow (current US$) of Uzbekistan in 1994 to that in 1997?
Offer a very short reply. 0.05. What is the ratio of the Aid flow (current US$) of Cuba in 1994 to that in 1998?
Your response must be concise. 0.84. What is the ratio of the Aid flow (current US$) of Kyrgyz Republic in 1994 to that in 1998?
Provide a succinct answer. 0.29. What is the ratio of the Aid flow (current US$) in Uzbekistan in 1994 to that in 1998?
Your answer should be very brief. 0.08. What is the ratio of the Aid flow (current US$) of Cuba in 1994 to that in 1999?
Ensure brevity in your answer.  0.55. What is the ratio of the Aid flow (current US$) of Kyrgyz Republic in 1994 to that in 1999?
Ensure brevity in your answer.  0.27. What is the ratio of the Aid flow (current US$) of Uzbekistan in 1994 to that in 1999?
Your response must be concise. 0.11. What is the ratio of the Aid flow (current US$) in Cuba in 1994 to that in 2010?
Offer a very short reply. 0.55. What is the ratio of the Aid flow (current US$) of Uzbekistan in 1994 to that in 2010?
Ensure brevity in your answer.  0.04. What is the ratio of the Aid flow (current US$) in Cuba in 1994 to that in 2011?
Offer a terse response. 0.49. What is the ratio of the Aid flow (current US$) in Kyrgyz Republic in 1994 to that in 2011?
Ensure brevity in your answer.  0.06. What is the ratio of the Aid flow (current US$) in Uzbekistan in 1994 to that in 2011?
Your response must be concise. 0.06. What is the ratio of the Aid flow (current US$) in Cuba in 1995 to that in 1997?
Provide a short and direct response. 0.89. What is the ratio of the Aid flow (current US$) of Kyrgyz Republic in 1995 to that in 1997?
Offer a very short reply. 1.79. What is the ratio of the Aid flow (current US$) of St. Kitts and Nevis in 1995 to that in 1997?
Your answer should be compact. 1. What is the ratio of the Aid flow (current US$) in Uzbekistan in 1995 to that in 1997?
Offer a very short reply. 2.18. What is the ratio of the Aid flow (current US$) in Cuba in 1995 to that in 1998?
Your response must be concise. 0.93. What is the ratio of the Aid flow (current US$) in Kyrgyz Republic in 1995 to that in 1998?
Offer a very short reply. 2.23. What is the ratio of the Aid flow (current US$) of St. Kitts and Nevis in 1995 to that in 1998?
Your response must be concise. 1. What is the ratio of the Aid flow (current US$) in Uzbekistan in 1995 to that in 1998?
Make the answer very short. 3.94. What is the ratio of the Aid flow (current US$) of Cuba in 1995 to that in 1999?
Your answer should be very brief. 0.61. What is the ratio of the Aid flow (current US$) of Kyrgyz Republic in 1995 to that in 1999?
Offer a very short reply. 2.09. What is the ratio of the Aid flow (current US$) of St. Kitts and Nevis in 1995 to that in 1999?
Offer a terse response. 0.33. What is the ratio of the Aid flow (current US$) of Uzbekistan in 1995 to that in 1999?
Offer a terse response. 5.21. What is the ratio of the Aid flow (current US$) of Cuba in 1995 to that in 2010?
Your answer should be very brief. 0.61. What is the ratio of the Aid flow (current US$) of Kyrgyz Republic in 1995 to that in 2010?
Ensure brevity in your answer.  0.61. What is the ratio of the Aid flow (current US$) of Uzbekistan in 1995 to that in 2010?
Your response must be concise. 1.86. What is the ratio of the Aid flow (current US$) in Cuba in 1995 to that in 2011?
Your response must be concise. 0.54. What is the ratio of the Aid flow (current US$) of Kyrgyz Republic in 1995 to that in 2011?
Give a very brief answer. 0.47. What is the ratio of the Aid flow (current US$) of St. Kitts and Nevis in 1995 to that in 2011?
Your answer should be very brief. 1. What is the ratio of the Aid flow (current US$) in Uzbekistan in 1995 to that in 2011?
Provide a succinct answer. 2.85. What is the ratio of the Aid flow (current US$) of Cuba in 1997 to that in 1998?
Your answer should be compact. 1.04. What is the ratio of the Aid flow (current US$) of Kyrgyz Republic in 1997 to that in 1998?
Your answer should be compact. 1.25. What is the ratio of the Aid flow (current US$) of Uzbekistan in 1997 to that in 1998?
Provide a succinct answer. 1.81. What is the ratio of the Aid flow (current US$) of Cuba in 1997 to that in 1999?
Provide a succinct answer. 0.69. What is the ratio of the Aid flow (current US$) of Kyrgyz Republic in 1997 to that in 1999?
Provide a short and direct response. 1.17. What is the ratio of the Aid flow (current US$) in Uzbekistan in 1997 to that in 1999?
Provide a succinct answer. 2.39. What is the ratio of the Aid flow (current US$) in Cuba in 1997 to that in 2010?
Give a very brief answer. 0.69. What is the ratio of the Aid flow (current US$) in Kyrgyz Republic in 1997 to that in 2010?
Your response must be concise. 0.34. What is the ratio of the Aid flow (current US$) in St. Kitts and Nevis in 1997 to that in 2010?
Your answer should be very brief. 0.2. What is the ratio of the Aid flow (current US$) in Uzbekistan in 1997 to that in 2010?
Provide a succinct answer. 0.85. What is the ratio of the Aid flow (current US$) in Cuba in 1997 to that in 2011?
Make the answer very short. 0.61. What is the ratio of the Aid flow (current US$) of Kyrgyz Republic in 1997 to that in 2011?
Give a very brief answer. 0.26. What is the ratio of the Aid flow (current US$) of Uzbekistan in 1997 to that in 2011?
Provide a succinct answer. 1.31. What is the ratio of the Aid flow (current US$) of Cuba in 1998 to that in 1999?
Your answer should be very brief. 0.66. What is the ratio of the Aid flow (current US$) of Kyrgyz Republic in 1998 to that in 1999?
Ensure brevity in your answer.  0.94. What is the ratio of the Aid flow (current US$) of Uzbekistan in 1998 to that in 1999?
Ensure brevity in your answer.  1.32. What is the ratio of the Aid flow (current US$) in Cuba in 1998 to that in 2010?
Your response must be concise. 0.66. What is the ratio of the Aid flow (current US$) in Kyrgyz Republic in 1998 to that in 2010?
Make the answer very short. 0.28. What is the ratio of the Aid flow (current US$) in St. Kitts and Nevis in 1998 to that in 2010?
Provide a short and direct response. 0.2. What is the ratio of the Aid flow (current US$) in Uzbekistan in 1998 to that in 2010?
Keep it short and to the point. 0.47. What is the ratio of the Aid flow (current US$) of Cuba in 1998 to that in 2011?
Your answer should be very brief. 0.58. What is the ratio of the Aid flow (current US$) in Kyrgyz Republic in 1998 to that in 2011?
Keep it short and to the point. 0.21. What is the ratio of the Aid flow (current US$) in St. Kitts and Nevis in 1998 to that in 2011?
Your response must be concise. 1. What is the ratio of the Aid flow (current US$) of Uzbekistan in 1998 to that in 2011?
Keep it short and to the point. 0.72. What is the ratio of the Aid flow (current US$) in Kyrgyz Republic in 1999 to that in 2010?
Ensure brevity in your answer.  0.29. What is the ratio of the Aid flow (current US$) of St. Kitts and Nevis in 1999 to that in 2010?
Your answer should be compact. 0.6. What is the ratio of the Aid flow (current US$) in Uzbekistan in 1999 to that in 2010?
Make the answer very short. 0.36. What is the ratio of the Aid flow (current US$) in Cuba in 1999 to that in 2011?
Offer a terse response. 0.88. What is the ratio of the Aid flow (current US$) in Kyrgyz Republic in 1999 to that in 2011?
Your answer should be very brief. 0.23. What is the ratio of the Aid flow (current US$) in St. Kitts and Nevis in 1999 to that in 2011?
Make the answer very short. 3. What is the ratio of the Aid flow (current US$) of Uzbekistan in 1999 to that in 2011?
Offer a very short reply. 0.55. What is the ratio of the Aid flow (current US$) of Cuba in 2010 to that in 2011?
Your answer should be compact. 0.88. What is the ratio of the Aid flow (current US$) of Kyrgyz Republic in 2010 to that in 2011?
Give a very brief answer. 0.77. What is the ratio of the Aid flow (current US$) in Uzbekistan in 2010 to that in 2011?
Offer a very short reply. 1.53. What is the difference between the highest and the second highest Aid flow (current US$) in Kyrgyz Republic?
Offer a terse response. 7.62e+06. What is the difference between the highest and the second highest Aid flow (current US$) of St. Kitts and Nevis?
Give a very brief answer. 2.00e+04. What is the difference between the highest and the second highest Aid flow (current US$) of Uzbekistan?
Offer a very short reply. 2.16e+07. What is the difference between the highest and the lowest Aid flow (current US$) of Cuba?
Give a very brief answer. 1.46e+06. What is the difference between the highest and the lowest Aid flow (current US$) of Kyrgyz Republic?
Provide a short and direct response. 3.08e+07. What is the difference between the highest and the lowest Aid flow (current US$) in Uzbekistan?
Make the answer very short. 4.57e+07. 